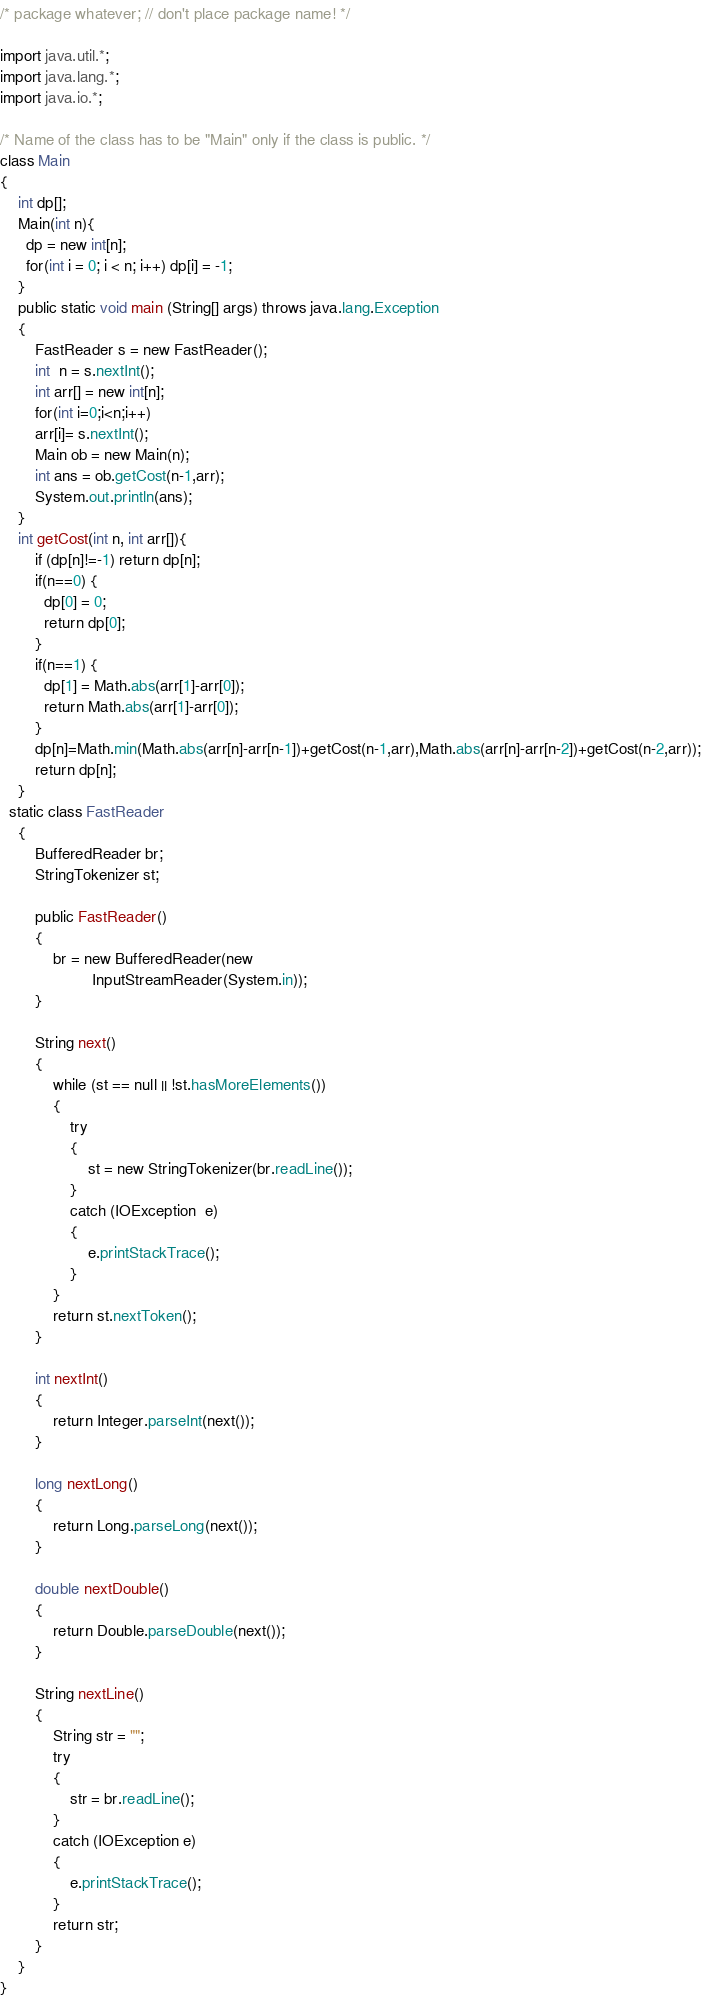Convert code to text. <code><loc_0><loc_0><loc_500><loc_500><_Java_>/* package whatever; // don't place package name! */

import java.util.*;
import java.lang.*;
import java.io.*;

/* Name of the class has to be "Main" only if the class is public. */
class Main
{
  	int dp[];
  	Main(int n){
      dp = new int[n];
      for(int i = 0; i < n; i++) dp[i] = -1;
    }
	public static void main (String[] args) throws java.lang.Exception
	{
      	FastReader s = new FastReader();
		int  n = s.nextInt();
		int arr[] = new int[n];
		for(int i=0;i<n;i++)
		arr[i]= s.nextInt();
		Main ob = new Main(n);
		int ans = ob.getCost(n-1,arr);
		System.out.println(ans);
	}
	int getCost(int n, int arr[]){
      	if (dp[n]!=-1) return dp[n];
		if(n==0) { 
          dp[0] = 0;
          return dp[0];
        }
		if(n==1) {
          dp[1] = Math.abs(arr[1]-arr[0]);
          return Math.abs(arr[1]-arr[0]);
        }
      	dp[n]=Math.min(Math.abs(arr[n]-arr[n-1])+getCost(n-1,arr),Math.abs(arr[n]-arr[n-2])+getCost(n-2,arr));
		return dp[n];
	}
  static class FastReader 
    { 
        BufferedReader br; 
        StringTokenizer st; 
  
        public FastReader() 
        { 
            br = new BufferedReader(new
                     InputStreamReader(System.in)); 
        } 
  
        String next() 
        { 
            while (st == null || !st.hasMoreElements()) 
            { 
                try
                { 
                    st = new StringTokenizer(br.readLine()); 
                } 
                catch (IOException  e) 
                { 
                    e.printStackTrace(); 
                } 
            } 
            return st.nextToken(); 
        } 
  
        int nextInt() 
        { 
            return Integer.parseInt(next()); 
        } 
  
        long nextLong() 
        { 
            return Long.parseLong(next()); 
        } 
  
        double nextDouble() 
        { 
            return Double.parseDouble(next()); 
        } 
  
        String nextLine() 
        { 
            String str = ""; 
            try
            { 
                str = br.readLine(); 
            } 
            catch (IOException e) 
            { 
                e.printStackTrace(); 
            } 
            return str; 
        } 
    } 
}
</code> 